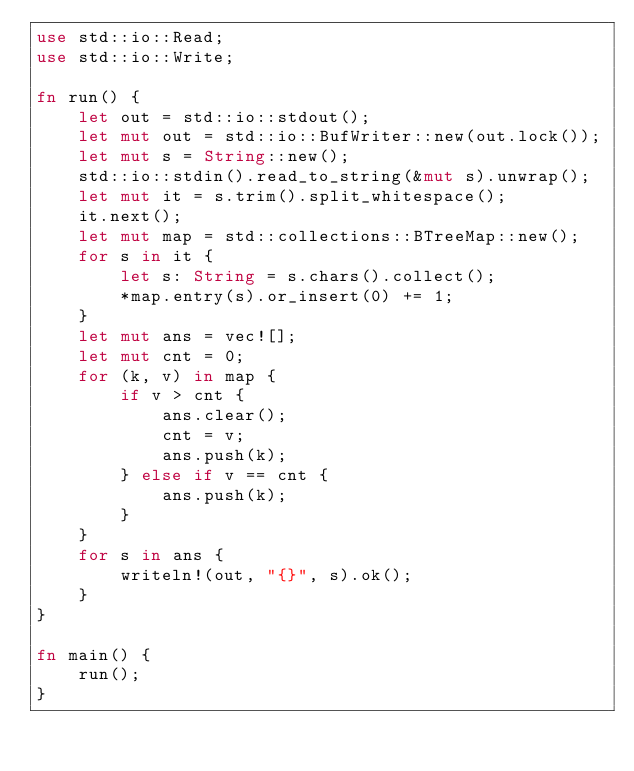Convert code to text. <code><loc_0><loc_0><loc_500><loc_500><_Rust_>use std::io::Read;
use std::io::Write;

fn run() {
    let out = std::io::stdout();
    let mut out = std::io::BufWriter::new(out.lock());
    let mut s = String::new();
    std::io::stdin().read_to_string(&mut s).unwrap();
    let mut it = s.trim().split_whitespace();
    it.next();
    let mut map = std::collections::BTreeMap::new();
    for s in it {
        let s: String = s.chars().collect();
        *map.entry(s).or_insert(0) += 1;
    }
    let mut ans = vec![];
    let mut cnt = 0;
    for (k, v) in map {
        if v > cnt {
            ans.clear();
            cnt = v;
            ans.push(k);
        } else if v == cnt {
            ans.push(k);
        }
    }
    for s in ans {
        writeln!(out, "{}", s).ok();
    }
}

fn main() {
    run();
}
</code> 